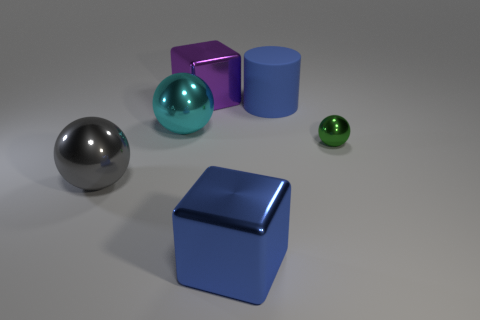What is the size of the other thing that is the same color as the rubber thing?
Your answer should be very brief. Large. What number of things are either big gray metal balls or large yellow rubber balls?
Your answer should be compact. 1. Is there any other thing that is made of the same material as the cylinder?
Give a very brief answer. No. Is there a blue thing?
Offer a terse response. Yes. Does the big block behind the cyan object have the same material as the blue cylinder?
Provide a short and direct response. No. Are there any green matte things of the same shape as the large gray shiny object?
Keep it short and to the point. No. Is the number of purple things left of the large cyan sphere the same as the number of tiny blue things?
Give a very brief answer. Yes. What is the material of the block to the left of the large block in front of the purple metallic thing?
Ensure brevity in your answer.  Metal. What is the shape of the rubber object?
Give a very brief answer. Cylinder. Are there an equal number of purple metal things that are in front of the tiny object and blue metallic blocks that are right of the purple block?
Offer a very short reply. No. 